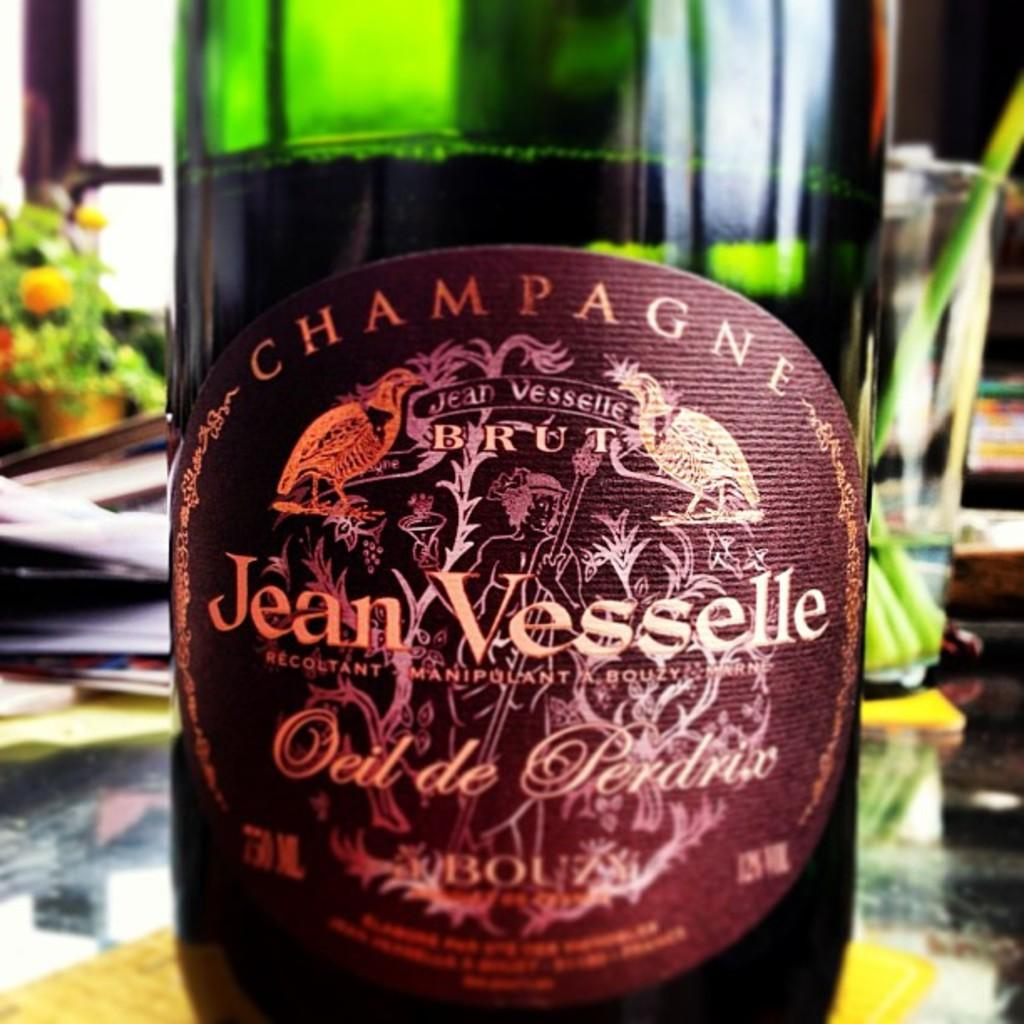<image>
Present a compact description of the photo's key features. The label of a Jean vesselle branded wine bottle. 